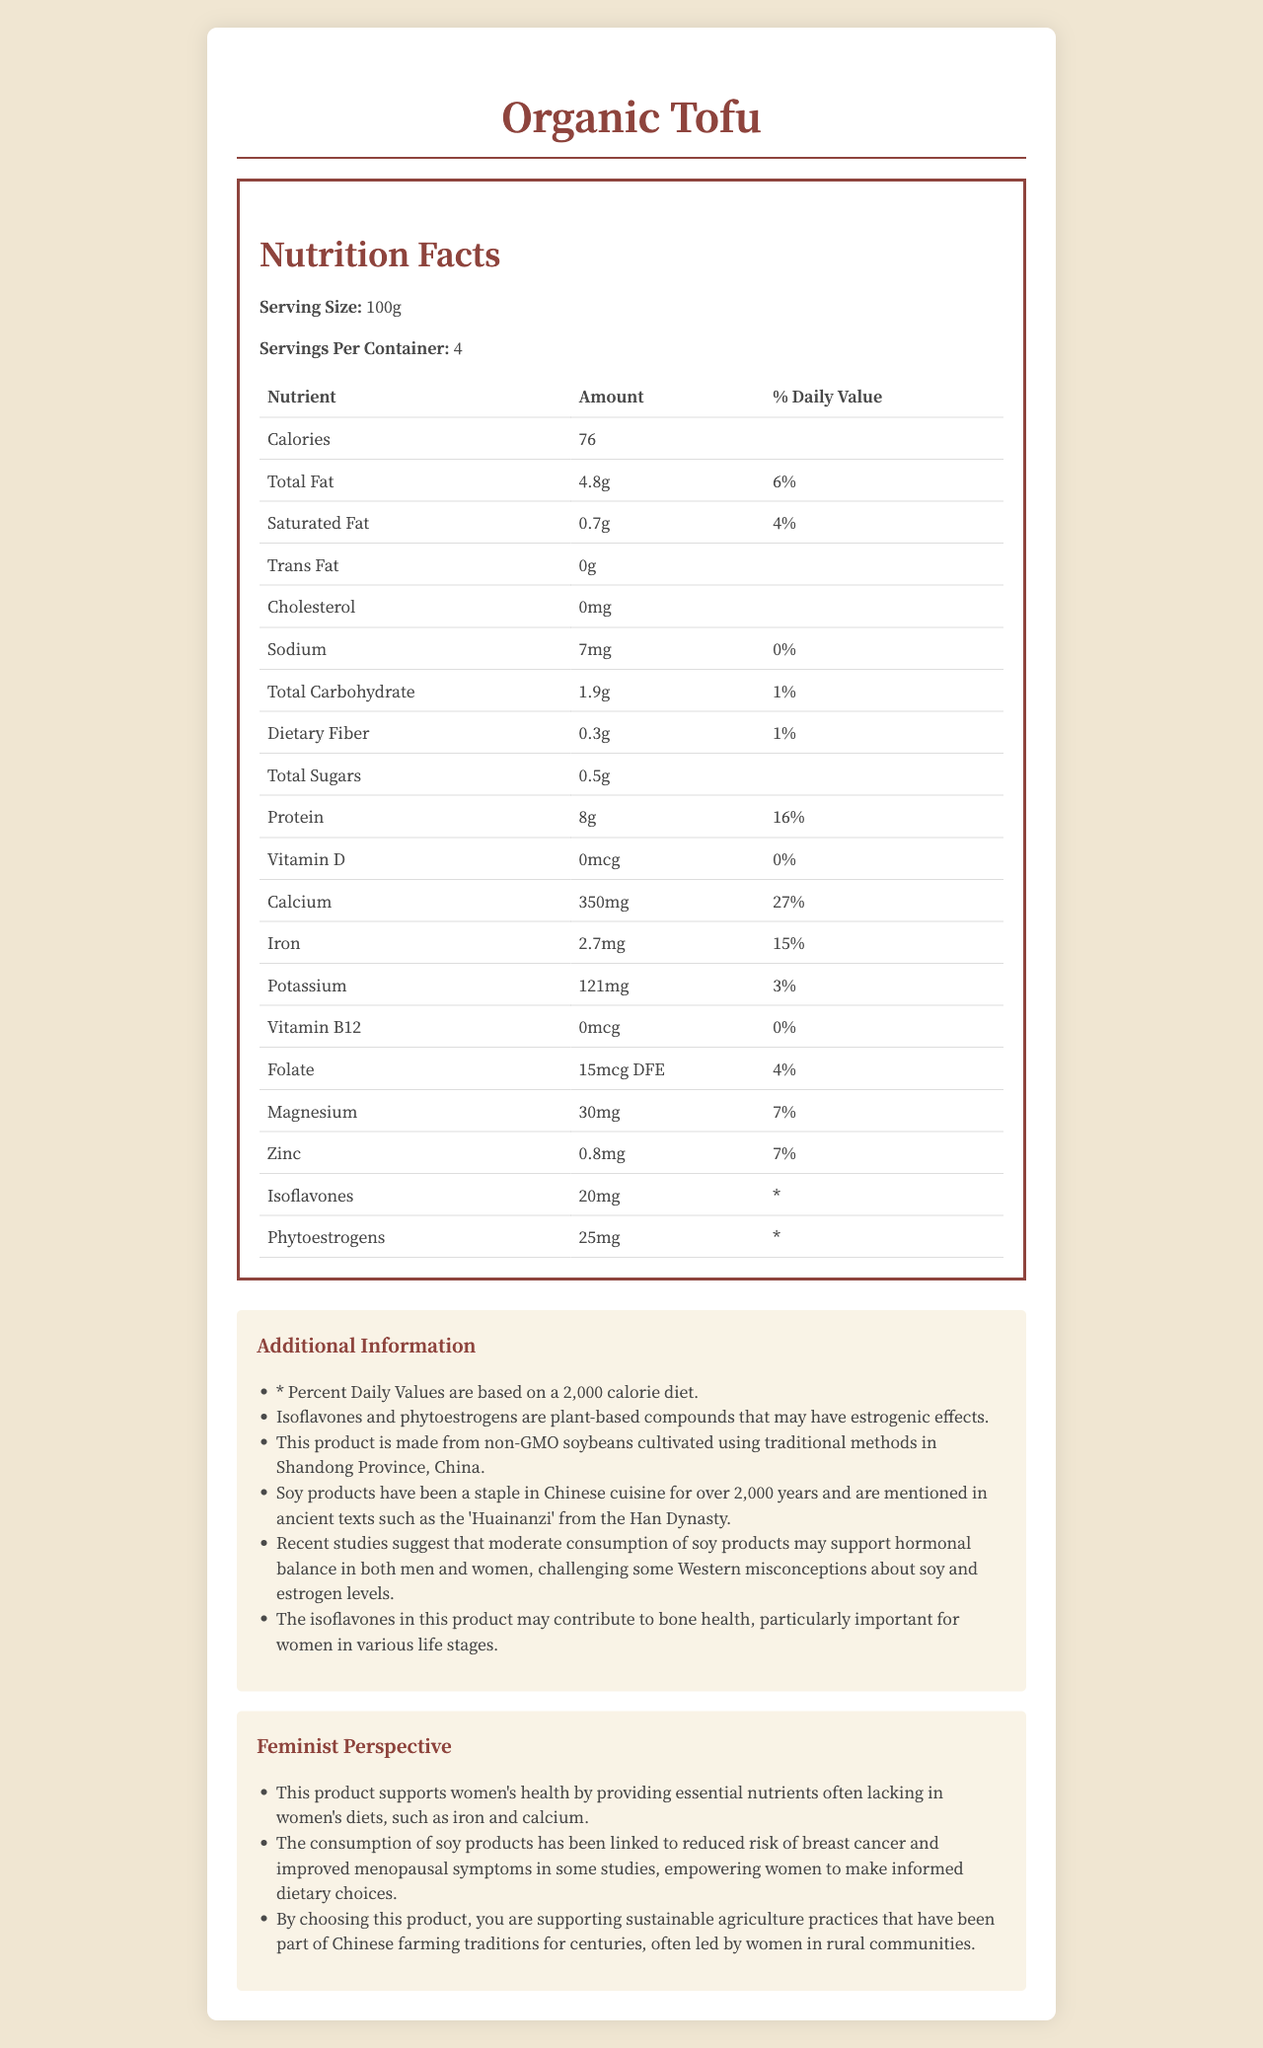What is the serving size of Organic Tofu? The serving size is specified under "Serving Size" on the nutrition label.
Answer: 100g How much calcium is in a serving of Organic Tofu? The amount of calcium can be found in the table under "Calcium".
Answer: 350mg What percentage of the daily value of iron does a serving of Organic Tofu provide? The percent daily value of iron is listed in the table under "Iron".
Answer: 15% List two micronutrients found in Organic Tofu that have a percent daily value of 7%. The percent daily values of 7% are listed in the table under "Magnesium" and "Zinc".
Answer: Magnesium, Zinc How much protein is in one serving of Organic Tofu? The amount of protein per serving is listed in the table under "Protein".
Answer: 8g Which of the following is not present in Organic Tofu? A. Trans Fat B. Cholesterol C. Vitamin B12 D. Saturated Fat According to the table, both Trans Fat and Cholesterol are listed as having "0" amount. However, Vitamin B12 has "0mcg", which still indicates absence.
Answer: B. Cholesterol What micronutrients in Organic Tofu are plant-based compounds that may have estrogenic effects? A. Isoflavones B. Folate C. Phytoestrogens D. Both A and C Additional information sections indicate that Isoflavones and Phytoestrogens are plant-based compounds with estrogenic effects.
Answer: D. Both A and C Does the product contain any cholesterol? The nutrition label lists "0mg" for cholesterol.
Answer: No Summarize the main health benefits of Organic Tofu from a feminist perspective. The feminist perspective section highlights these benefits, emphasizing women's health, informed dietary choices, and women's roles in sustainable agriculture.
Answer: The main health benefits include essential nutrients like iron and calcium, reducing breast cancer risk, improved menopausal symptoms, and promotion of sustainable agriculture practices led by women. What is the relationship between isoflavones and bone health in women according to the document? The additional information mentions that isoflavones in the product may support bone health.
Answer: Isoflavones may contribute to bone health, particularly important for women in various life stages. What traditional Chinese text mentioned soy products, reflecting their long history in Chinese cuisine? The additional information section states that soy products are mentioned in the 'Huainanzi', an ancient text from the Han Dynasty.
Answer: 'Huainanzi' from the Han Dynasty Where are the soybeans for Organic Tofu cultivated? The additional information specifies that the soybeans are cultivated using traditional methods in Shandong Province, China.
Answer: Shandong Province, China How does the document suggest soy products impact hormonal balance? This information is found in the additional information section.
Answer: Recent studies suggest that moderate consumption of soy products may support hormonal balance in both men and women. Can we determine the exact amount of phytoestrogens' percent daily value from the document? The table indicates an asterisk (*) for the percent daily values of phytoestrogens, meaning it's not provided.
Answer: No 